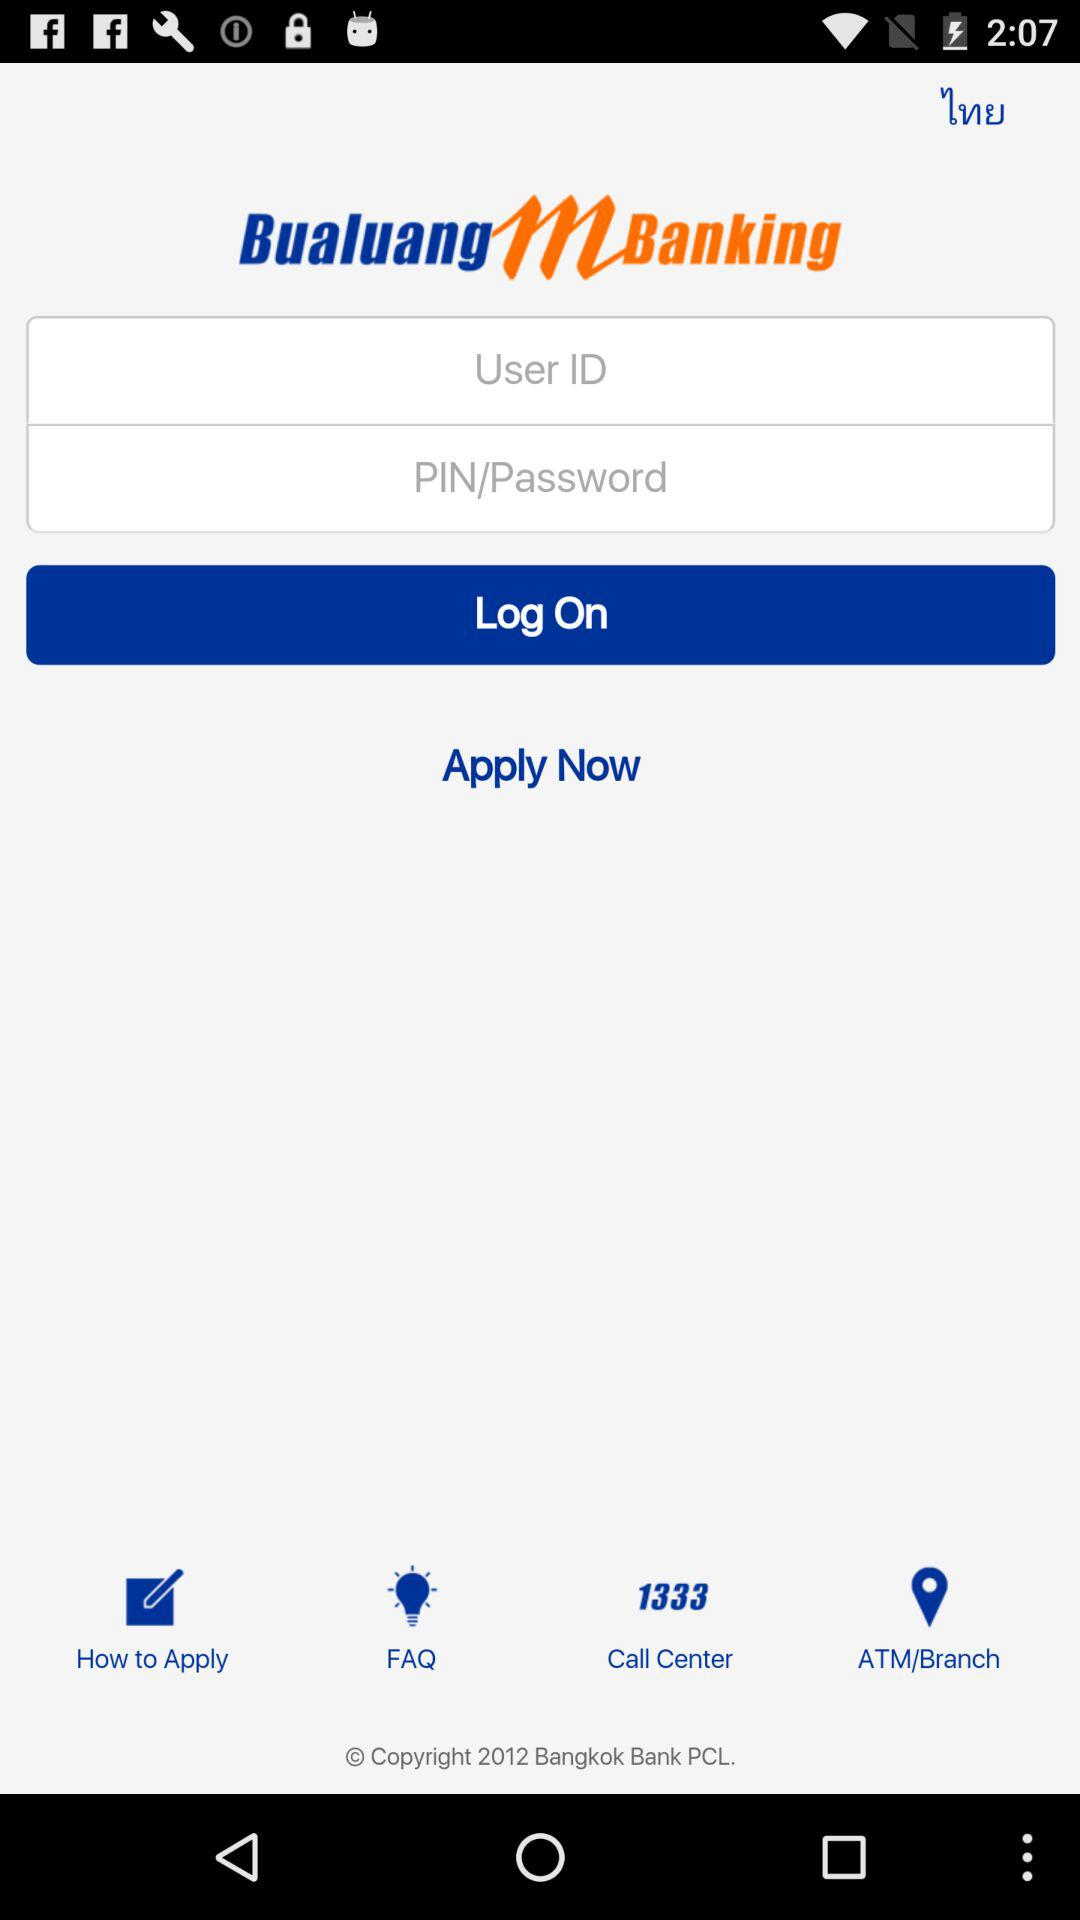What is the call center number? The call center number is 1333. 